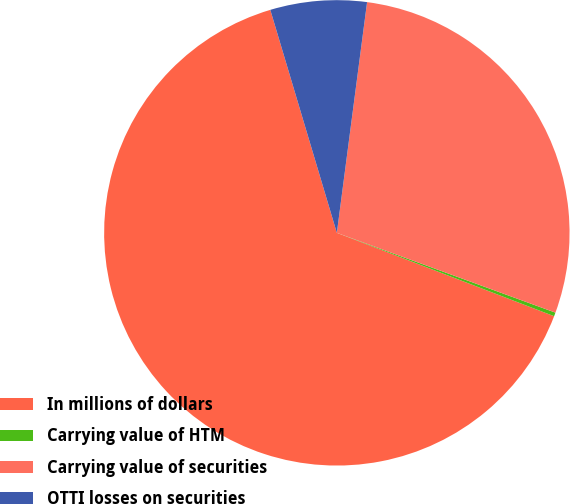Convert chart. <chart><loc_0><loc_0><loc_500><loc_500><pie_chart><fcel>In millions of dollars<fcel>Carrying value of HTM<fcel>Carrying value of securities<fcel>OTTI losses on securities<nl><fcel>64.56%<fcel>0.26%<fcel>28.5%<fcel>6.69%<nl></chart> 